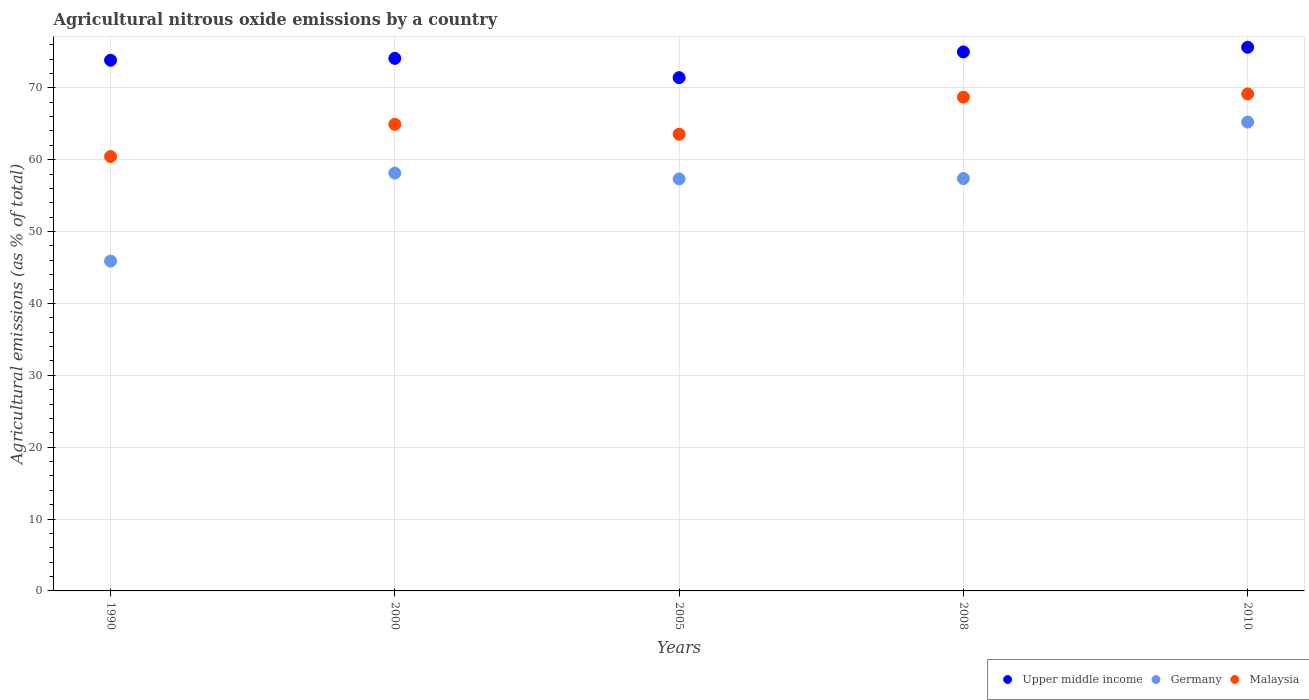Is the number of dotlines equal to the number of legend labels?
Offer a very short reply. Yes. What is the amount of agricultural nitrous oxide emitted in Germany in 2005?
Provide a short and direct response. 57.32. Across all years, what is the maximum amount of agricultural nitrous oxide emitted in Malaysia?
Keep it short and to the point. 69.16. Across all years, what is the minimum amount of agricultural nitrous oxide emitted in Upper middle income?
Ensure brevity in your answer.  71.42. In which year was the amount of agricultural nitrous oxide emitted in Germany maximum?
Provide a short and direct response. 2010. What is the total amount of agricultural nitrous oxide emitted in Malaysia in the graph?
Give a very brief answer. 326.76. What is the difference between the amount of agricultural nitrous oxide emitted in Germany in 2000 and that in 2010?
Offer a very short reply. -7.09. What is the difference between the amount of agricultural nitrous oxide emitted in Upper middle income in 2005 and the amount of agricultural nitrous oxide emitted in Germany in 1990?
Ensure brevity in your answer.  25.53. What is the average amount of agricultural nitrous oxide emitted in Germany per year?
Give a very brief answer. 56.79. In the year 2005, what is the difference between the amount of agricultural nitrous oxide emitted in Germany and amount of agricultural nitrous oxide emitted in Malaysia?
Keep it short and to the point. -6.22. What is the ratio of the amount of agricultural nitrous oxide emitted in Upper middle income in 2000 to that in 2010?
Provide a succinct answer. 0.98. Is the difference between the amount of agricultural nitrous oxide emitted in Germany in 1990 and 2005 greater than the difference between the amount of agricultural nitrous oxide emitted in Malaysia in 1990 and 2005?
Provide a short and direct response. No. What is the difference between the highest and the second highest amount of agricultural nitrous oxide emitted in Upper middle income?
Offer a terse response. 0.65. What is the difference between the highest and the lowest amount of agricultural nitrous oxide emitted in Upper middle income?
Your response must be concise. 4.23. Is the amount of agricultural nitrous oxide emitted in Malaysia strictly greater than the amount of agricultural nitrous oxide emitted in Germany over the years?
Provide a short and direct response. Yes. Is the amount of agricultural nitrous oxide emitted in Germany strictly less than the amount of agricultural nitrous oxide emitted in Upper middle income over the years?
Make the answer very short. Yes. How many dotlines are there?
Your answer should be compact. 3. How many years are there in the graph?
Give a very brief answer. 5. Does the graph contain any zero values?
Your answer should be compact. No. How many legend labels are there?
Provide a succinct answer. 3. How are the legend labels stacked?
Offer a terse response. Horizontal. What is the title of the graph?
Provide a succinct answer. Agricultural nitrous oxide emissions by a country. What is the label or title of the X-axis?
Give a very brief answer. Years. What is the label or title of the Y-axis?
Your response must be concise. Agricultural emissions (as % of total). What is the Agricultural emissions (as % of total) of Upper middle income in 1990?
Your response must be concise. 73.84. What is the Agricultural emissions (as % of total) in Germany in 1990?
Ensure brevity in your answer.  45.89. What is the Agricultural emissions (as % of total) of Malaysia in 1990?
Offer a very short reply. 60.44. What is the Agricultural emissions (as % of total) in Upper middle income in 2000?
Offer a terse response. 74.1. What is the Agricultural emissions (as % of total) of Germany in 2000?
Offer a very short reply. 58.14. What is the Agricultural emissions (as % of total) in Malaysia in 2000?
Your response must be concise. 64.92. What is the Agricultural emissions (as % of total) of Upper middle income in 2005?
Your response must be concise. 71.42. What is the Agricultural emissions (as % of total) of Germany in 2005?
Offer a terse response. 57.32. What is the Agricultural emissions (as % of total) of Malaysia in 2005?
Give a very brief answer. 63.54. What is the Agricultural emissions (as % of total) of Upper middle income in 2008?
Your response must be concise. 75. What is the Agricultural emissions (as % of total) of Germany in 2008?
Keep it short and to the point. 57.38. What is the Agricultural emissions (as % of total) in Malaysia in 2008?
Provide a short and direct response. 68.7. What is the Agricultural emissions (as % of total) of Upper middle income in 2010?
Provide a short and direct response. 75.64. What is the Agricultural emissions (as % of total) of Germany in 2010?
Give a very brief answer. 65.23. What is the Agricultural emissions (as % of total) in Malaysia in 2010?
Provide a succinct answer. 69.16. Across all years, what is the maximum Agricultural emissions (as % of total) in Upper middle income?
Your answer should be very brief. 75.64. Across all years, what is the maximum Agricultural emissions (as % of total) of Germany?
Your answer should be very brief. 65.23. Across all years, what is the maximum Agricultural emissions (as % of total) of Malaysia?
Your answer should be very brief. 69.16. Across all years, what is the minimum Agricultural emissions (as % of total) of Upper middle income?
Offer a terse response. 71.42. Across all years, what is the minimum Agricultural emissions (as % of total) of Germany?
Give a very brief answer. 45.89. Across all years, what is the minimum Agricultural emissions (as % of total) of Malaysia?
Give a very brief answer. 60.44. What is the total Agricultural emissions (as % of total) in Upper middle income in the graph?
Offer a terse response. 370. What is the total Agricultural emissions (as % of total) in Germany in the graph?
Make the answer very short. 283.97. What is the total Agricultural emissions (as % of total) of Malaysia in the graph?
Give a very brief answer. 326.76. What is the difference between the Agricultural emissions (as % of total) of Upper middle income in 1990 and that in 2000?
Your answer should be very brief. -0.26. What is the difference between the Agricultural emissions (as % of total) of Germany in 1990 and that in 2000?
Provide a short and direct response. -12.25. What is the difference between the Agricultural emissions (as % of total) in Malaysia in 1990 and that in 2000?
Offer a very short reply. -4.47. What is the difference between the Agricultural emissions (as % of total) in Upper middle income in 1990 and that in 2005?
Keep it short and to the point. 2.42. What is the difference between the Agricultural emissions (as % of total) of Germany in 1990 and that in 2005?
Ensure brevity in your answer.  -11.43. What is the difference between the Agricultural emissions (as % of total) in Malaysia in 1990 and that in 2005?
Offer a very short reply. -3.1. What is the difference between the Agricultural emissions (as % of total) in Upper middle income in 1990 and that in 2008?
Make the answer very short. -1.16. What is the difference between the Agricultural emissions (as % of total) in Germany in 1990 and that in 2008?
Offer a terse response. -11.49. What is the difference between the Agricultural emissions (as % of total) in Malaysia in 1990 and that in 2008?
Ensure brevity in your answer.  -8.26. What is the difference between the Agricultural emissions (as % of total) of Upper middle income in 1990 and that in 2010?
Your answer should be very brief. -1.8. What is the difference between the Agricultural emissions (as % of total) in Germany in 1990 and that in 2010?
Provide a short and direct response. -19.34. What is the difference between the Agricultural emissions (as % of total) in Malaysia in 1990 and that in 2010?
Make the answer very short. -8.71. What is the difference between the Agricultural emissions (as % of total) of Upper middle income in 2000 and that in 2005?
Offer a very short reply. 2.68. What is the difference between the Agricultural emissions (as % of total) in Germany in 2000 and that in 2005?
Give a very brief answer. 0.82. What is the difference between the Agricultural emissions (as % of total) in Malaysia in 2000 and that in 2005?
Ensure brevity in your answer.  1.38. What is the difference between the Agricultural emissions (as % of total) of Upper middle income in 2000 and that in 2008?
Make the answer very short. -0.9. What is the difference between the Agricultural emissions (as % of total) of Germany in 2000 and that in 2008?
Make the answer very short. 0.76. What is the difference between the Agricultural emissions (as % of total) of Malaysia in 2000 and that in 2008?
Your answer should be compact. -3.79. What is the difference between the Agricultural emissions (as % of total) of Upper middle income in 2000 and that in 2010?
Your answer should be compact. -1.54. What is the difference between the Agricultural emissions (as % of total) in Germany in 2000 and that in 2010?
Ensure brevity in your answer.  -7.09. What is the difference between the Agricultural emissions (as % of total) in Malaysia in 2000 and that in 2010?
Your response must be concise. -4.24. What is the difference between the Agricultural emissions (as % of total) of Upper middle income in 2005 and that in 2008?
Provide a succinct answer. -3.58. What is the difference between the Agricultural emissions (as % of total) of Germany in 2005 and that in 2008?
Ensure brevity in your answer.  -0.06. What is the difference between the Agricultural emissions (as % of total) of Malaysia in 2005 and that in 2008?
Ensure brevity in your answer.  -5.16. What is the difference between the Agricultural emissions (as % of total) in Upper middle income in 2005 and that in 2010?
Your answer should be compact. -4.23. What is the difference between the Agricultural emissions (as % of total) of Germany in 2005 and that in 2010?
Offer a terse response. -7.91. What is the difference between the Agricultural emissions (as % of total) in Malaysia in 2005 and that in 2010?
Your answer should be compact. -5.62. What is the difference between the Agricultural emissions (as % of total) of Upper middle income in 2008 and that in 2010?
Keep it short and to the point. -0.65. What is the difference between the Agricultural emissions (as % of total) in Germany in 2008 and that in 2010?
Provide a succinct answer. -7.86. What is the difference between the Agricultural emissions (as % of total) of Malaysia in 2008 and that in 2010?
Provide a short and direct response. -0.45. What is the difference between the Agricultural emissions (as % of total) of Upper middle income in 1990 and the Agricultural emissions (as % of total) of Germany in 2000?
Provide a short and direct response. 15.7. What is the difference between the Agricultural emissions (as % of total) in Upper middle income in 1990 and the Agricultural emissions (as % of total) in Malaysia in 2000?
Provide a short and direct response. 8.92. What is the difference between the Agricultural emissions (as % of total) of Germany in 1990 and the Agricultural emissions (as % of total) of Malaysia in 2000?
Provide a short and direct response. -19.03. What is the difference between the Agricultural emissions (as % of total) in Upper middle income in 1990 and the Agricultural emissions (as % of total) in Germany in 2005?
Provide a succinct answer. 16.52. What is the difference between the Agricultural emissions (as % of total) of Upper middle income in 1990 and the Agricultural emissions (as % of total) of Malaysia in 2005?
Ensure brevity in your answer.  10.3. What is the difference between the Agricultural emissions (as % of total) in Germany in 1990 and the Agricultural emissions (as % of total) in Malaysia in 2005?
Offer a very short reply. -17.65. What is the difference between the Agricultural emissions (as % of total) of Upper middle income in 1990 and the Agricultural emissions (as % of total) of Germany in 2008?
Your answer should be very brief. 16.46. What is the difference between the Agricultural emissions (as % of total) in Upper middle income in 1990 and the Agricultural emissions (as % of total) in Malaysia in 2008?
Your answer should be compact. 5.13. What is the difference between the Agricultural emissions (as % of total) of Germany in 1990 and the Agricultural emissions (as % of total) of Malaysia in 2008?
Offer a very short reply. -22.81. What is the difference between the Agricultural emissions (as % of total) of Upper middle income in 1990 and the Agricultural emissions (as % of total) of Germany in 2010?
Offer a very short reply. 8.61. What is the difference between the Agricultural emissions (as % of total) in Upper middle income in 1990 and the Agricultural emissions (as % of total) in Malaysia in 2010?
Provide a short and direct response. 4.68. What is the difference between the Agricultural emissions (as % of total) of Germany in 1990 and the Agricultural emissions (as % of total) of Malaysia in 2010?
Make the answer very short. -23.26. What is the difference between the Agricultural emissions (as % of total) of Upper middle income in 2000 and the Agricultural emissions (as % of total) of Germany in 2005?
Provide a succinct answer. 16.78. What is the difference between the Agricultural emissions (as % of total) in Upper middle income in 2000 and the Agricultural emissions (as % of total) in Malaysia in 2005?
Provide a short and direct response. 10.56. What is the difference between the Agricultural emissions (as % of total) of Germany in 2000 and the Agricultural emissions (as % of total) of Malaysia in 2005?
Offer a very short reply. -5.4. What is the difference between the Agricultural emissions (as % of total) of Upper middle income in 2000 and the Agricultural emissions (as % of total) of Germany in 2008?
Your response must be concise. 16.72. What is the difference between the Agricultural emissions (as % of total) in Upper middle income in 2000 and the Agricultural emissions (as % of total) in Malaysia in 2008?
Your answer should be compact. 5.39. What is the difference between the Agricultural emissions (as % of total) in Germany in 2000 and the Agricultural emissions (as % of total) in Malaysia in 2008?
Make the answer very short. -10.56. What is the difference between the Agricultural emissions (as % of total) of Upper middle income in 2000 and the Agricultural emissions (as % of total) of Germany in 2010?
Your response must be concise. 8.86. What is the difference between the Agricultural emissions (as % of total) of Upper middle income in 2000 and the Agricultural emissions (as % of total) of Malaysia in 2010?
Provide a succinct answer. 4.94. What is the difference between the Agricultural emissions (as % of total) of Germany in 2000 and the Agricultural emissions (as % of total) of Malaysia in 2010?
Offer a very short reply. -11.01. What is the difference between the Agricultural emissions (as % of total) in Upper middle income in 2005 and the Agricultural emissions (as % of total) in Germany in 2008?
Your answer should be compact. 14.04. What is the difference between the Agricultural emissions (as % of total) in Upper middle income in 2005 and the Agricultural emissions (as % of total) in Malaysia in 2008?
Your answer should be very brief. 2.71. What is the difference between the Agricultural emissions (as % of total) in Germany in 2005 and the Agricultural emissions (as % of total) in Malaysia in 2008?
Make the answer very short. -11.38. What is the difference between the Agricultural emissions (as % of total) of Upper middle income in 2005 and the Agricultural emissions (as % of total) of Germany in 2010?
Your answer should be compact. 6.18. What is the difference between the Agricultural emissions (as % of total) in Upper middle income in 2005 and the Agricultural emissions (as % of total) in Malaysia in 2010?
Offer a very short reply. 2.26. What is the difference between the Agricultural emissions (as % of total) in Germany in 2005 and the Agricultural emissions (as % of total) in Malaysia in 2010?
Your answer should be very brief. -11.84. What is the difference between the Agricultural emissions (as % of total) in Upper middle income in 2008 and the Agricultural emissions (as % of total) in Germany in 2010?
Provide a succinct answer. 9.76. What is the difference between the Agricultural emissions (as % of total) in Upper middle income in 2008 and the Agricultural emissions (as % of total) in Malaysia in 2010?
Ensure brevity in your answer.  5.84. What is the difference between the Agricultural emissions (as % of total) in Germany in 2008 and the Agricultural emissions (as % of total) in Malaysia in 2010?
Provide a short and direct response. -11.78. What is the average Agricultural emissions (as % of total) of Upper middle income per year?
Make the answer very short. 74. What is the average Agricultural emissions (as % of total) of Germany per year?
Offer a terse response. 56.79. What is the average Agricultural emissions (as % of total) of Malaysia per year?
Keep it short and to the point. 65.35. In the year 1990, what is the difference between the Agricultural emissions (as % of total) of Upper middle income and Agricultural emissions (as % of total) of Germany?
Your answer should be compact. 27.95. In the year 1990, what is the difference between the Agricultural emissions (as % of total) of Upper middle income and Agricultural emissions (as % of total) of Malaysia?
Give a very brief answer. 13.4. In the year 1990, what is the difference between the Agricultural emissions (as % of total) of Germany and Agricultural emissions (as % of total) of Malaysia?
Your answer should be compact. -14.55. In the year 2000, what is the difference between the Agricultural emissions (as % of total) in Upper middle income and Agricultural emissions (as % of total) in Germany?
Your answer should be compact. 15.96. In the year 2000, what is the difference between the Agricultural emissions (as % of total) in Upper middle income and Agricultural emissions (as % of total) in Malaysia?
Your response must be concise. 9.18. In the year 2000, what is the difference between the Agricultural emissions (as % of total) in Germany and Agricultural emissions (as % of total) in Malaysia?
Provide a succinct answer. -6.78. In the year 2005, what is the difference between the Agricultural emissions (as % of total) of Upper middle income and Agricultural emissions (as % of total) of Germany?
Provide a short and direct response. 14.1. In the year 2005, what is the difference between the Agricultural emissions (as % of total) of Upper middle income and Agricultural emissions (as % of total) of Malaysia?
Ensure brevity in your answer.  7.88. In the year 2005, what is the difference between the Agricultural emissions (as % of total) in Germany and Agricultural emissions (as % of total) in Malaysia?
Keep it short and to the point. -6.22. In the year 2008, what is the difference between the Agricultural emissions (as % of total) in Upper middle income and Agricultural emissions (as % of total) in Germany?
Make the answer very short. 17.62. In the year 2008, what is the difference between the Agricultural emissions (as % of total) in Upper middle income and Agricultural emissions (as % of total) in Malaysia?
Ensure brevity in your answer.  6.29. In the year 2008, what is the difference between the Agricultural emissions (as % of total) of Germany and Agricultural emissions (as % of total) of Malaysia?
Your answer should be very brief. -11.33. In the year 2010, what is the difference between the Agricultural emissions (as % of total) of Upper middle income and Agricultural emissions (as % of total) of Germany?
Provide a succinct answer. 10.41. In the year 2010, what is the difference between the Agricultural emissions (as % of total) in Upper middle income and Agricultural emissions (as % of total) in Malaysia?
Keep it short and to the point. 6.49. In the year 2010, what is the difference between the Agricultural emissions (as % of total) in Germany and Agricultural emissions (as % of total) in Malaysia?
Keep it short and to the point. -3.92. What is the ratio of the Agricultural emissions (as % of total) of Upper middle income in 1990 to that in 2000?
Provide a short and direct response. 1. What is the ratio of the Agricultural emissions (as % of total) of Germany in 1990 to that in 2000?
Make the answer very short. 0.79. What is the ratio of the Agricultural emissions (as % of total) of Malaysia in 1990 to that in 2000?
Ensure brevity in your answer.  0.93. What is the ratio of the Agricultural emissions (as % of total) of Upper middle income in 1990 to that in 2005?
Keep it short and to the point. 1.03. What is the ratio of the Agricultural emissions (as % of total) in Germany in 1990 to that in 2005?
Provide a succinct answer. 0.8. What is the ratio of the Agricultural emissions (as % of total) of Malaysia in 1990 to that in 2005?
Provide a succinct answer. 0.95. What is the ratio of the Agricultural emissions (as % of total) of Upper middle income in 1990 to that in 2008?
Provide a short and direct response. 0.98. What is the ratio of the Agricultural emissions (as % of total) of Germany in 1990 to that in 2008?
Keep it short and to the point. 0.8. What is the ratio of the Agricultural emissions (as % of total) in Malaysia in 1990 to that in 2008?
Your answer should be very brief. 0.88. What is the ratio of the Agricultural emissions (as % of total) of Upper middle income in 1990 to that in 2010?
Provide a short and direct response. 0.98. What is the ratio of the Agricultural emissions (as % of total) of Germany in 1990 to that in 2010?
Keep it short and to the point. 0.7. What is the ratio of the Agricultural emissions (as % of total) of Malaysia in 1990 to that in 2010?
Provide a short and direct response. 0.87. What is the ratio of the Agricultural emissions (as % of total) in Upper middle income in 2000 to that in 2005?
Your response must be concise. 1.04. What is the ratio of the Agricultural emissions (as % of total) in Germany in 2000 to that in 2005?
Provide a short and direct response. 1.01. What is the ratio of the Agricultural emissions (as % of total) of Malaysia in 2000 to that in 2005?
Ensure brevity in your answer.  1.02. What is the ratio of the Agricultural emissions (as % of total) of Upper middle income in 2000 to that in 2008?
Your answer should be very brief. 0.99. What is the ratio of the Agricultural emissions (as % of total) in Germany in 2000 to that in 2008?
Provide a short and direct response. 1.01. What is the ratio of the Agricultural emissions (as % of total) of Malaysia in 2000 to that in 2008?
Ensure brevity in your answer.  0.94. What is the ratio of the Agricultural emissions (as % of total) of Upper middle income in 2000 to that in 2010?
Offer a terse response. 0.98. What is the ratio of the Agricultural emissions (as % of total) in Germany in 2000 to that in 2010?
Your response must be concise. 0.89. What is the ratio of the Agricultural emissions (as % of total) in Malaysia in 2000 to that in 2010?
Ensure brevity in your answer.  0.94. What is the ratio of the Agricultural emissions (as % of total) in Upper middle income in 2005 to that in 2008?
Make the answer very short. 0.95. What is the ratio of the Agricultural emissions (as % of total) in Malaysia in 2005 to that in 2008?
Keep it short and to the point. 0.92. What is the ratio of the Agricultural emissions (as % of total) in Upper middle income in 2005 to that in 2010?
Your answer should be very brief. 0.94. What is the ratio of the Agricultural emissions (as % of total) in Germany in 2005 to that in 2010?
Make the answer very short. 0.88. What is the ratio of the Agricultural emissions (as % of total) in Malaysia in 2005 to that in 2010?
Your answer should be compact. 0.92. What is the ratio of the Agricultural emissions (as % of total) in Upper middle income in 2008 to that in 2010?
Keep it short and to the point. 0.99. What is the ratio of the Agricultural emissions (as % of total) in Germany in 2008 to that in 2010?
Your response must be concise. 0.88. What is the difference between the highest and the second highest Agricultural emissions (as % of total) in Upper middle income?
Your answer should be very brief. 0.65. What is the difference between the highest and the second highest Agricultural emissions (as % of total) of Germany?
Provide a succinct answer. 7.09. What is the difference between the highest and the second highest Agricultural emissions (as % of total) in Malaysia?
Your answer should be compact. 0.45. What is the difference between the highest and the lowest Agricultural emissions (as % of total) of Upper middle income?
Ensure brevity in your answer.  4.23. What is the difference between the highest and the lowest Agricultural emissions (as % of total) of Germany?
Give a very brief answer. 19.34. What is the difference between the highest and the lowest Agricultural emissions (as % of total) of Malaysia?
Your response must be concise. 8.71. 